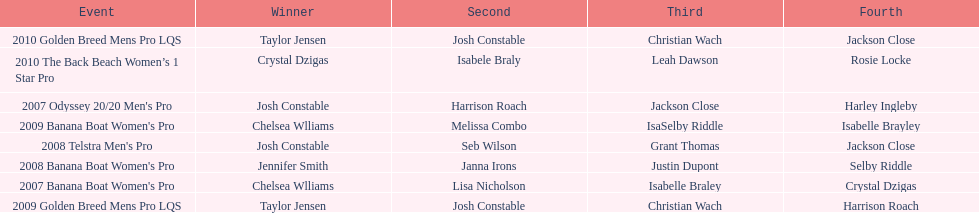What is the total number of times chelsea williams was the winner between 2007 and 2010? 2. 